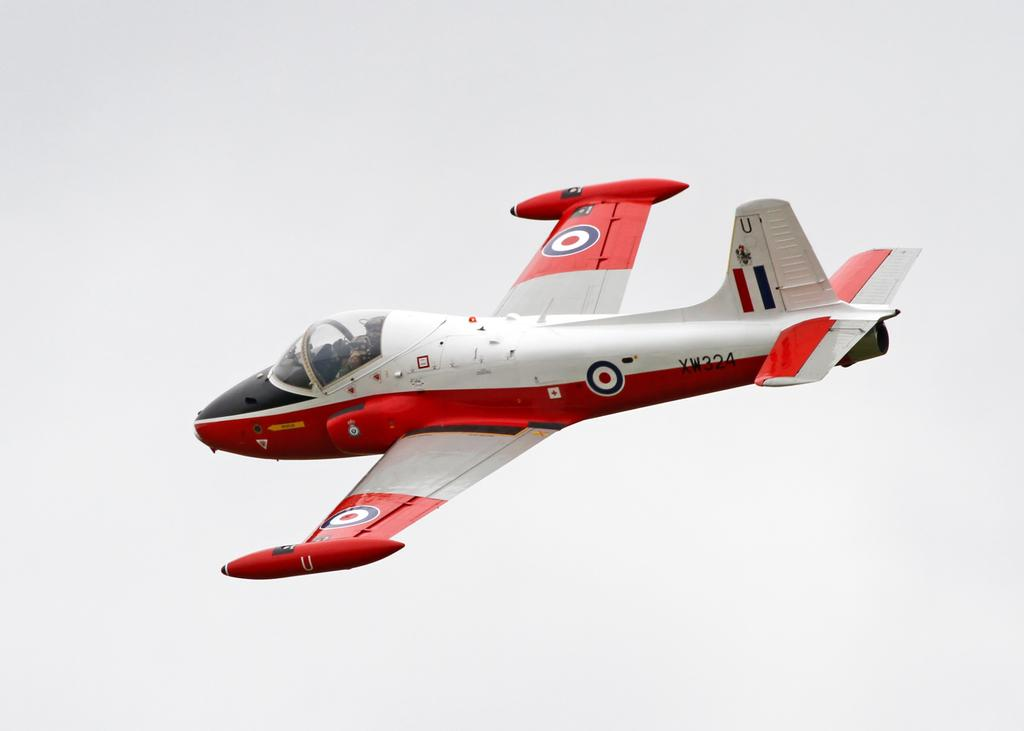<image>
Summarize the visual content of the image. A red and white plane is flying in the air with XW324 on the tail. 